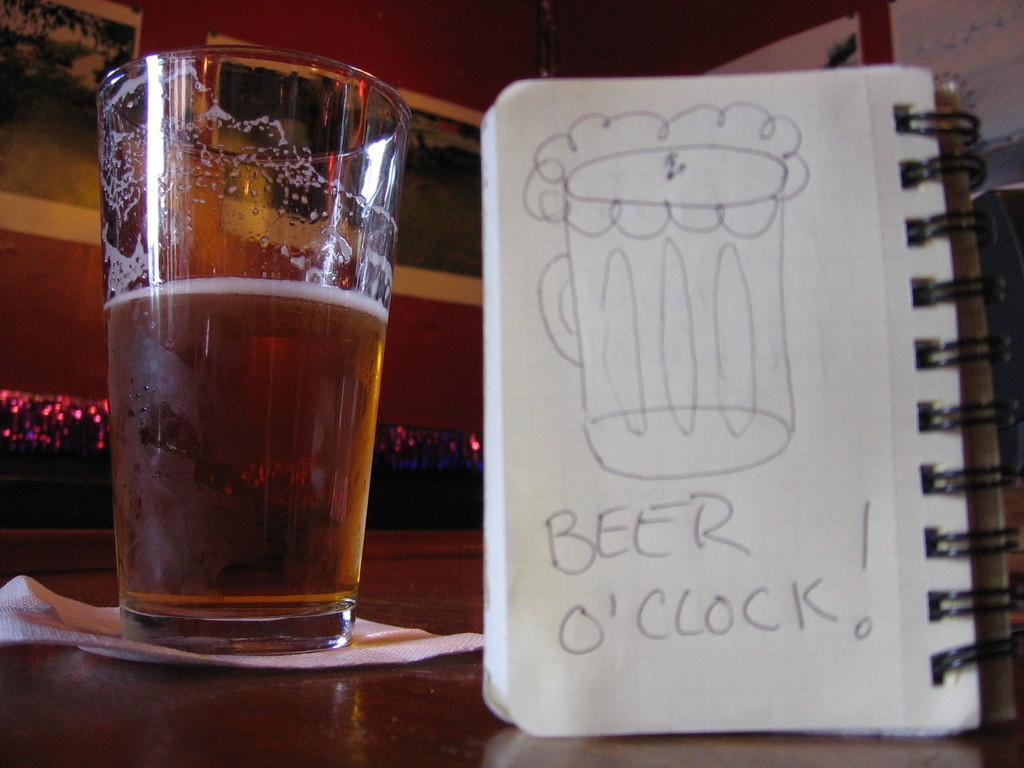<image>
Relay a brief, clear account of the picture shown. a picture of Beer o'clock next to a full ber 